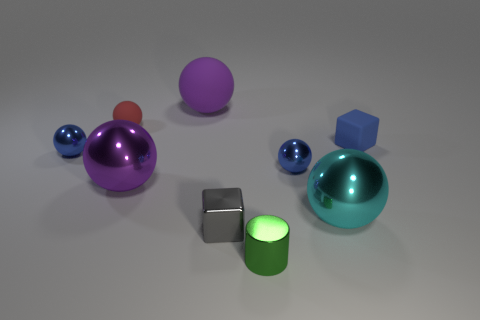Do the green object and the blue cube have the same size?
Your answer should be compact. Yes. Is the number of tiny shiny blocks behind the blue rubber block greater than the number of purple rubber spheres to the right of the cyan thing?
Make the answer very short. No. How many other things are the same size as the shiny cube?
Your answer should be very brief. 5. Is the color of the large metal thing that is on the right side of the purple matte ball the same as the tiny rubber ball?
Provide a short and direct response. No. Is the number of cyan balls that are left of the tiny gray object greater than the number of red metallic cylinders?
Offer a very short reply. No. Is there any other thing that has the same color as the small cylinder?
Provide a short and direct response. No. The big purple object behind the small thing that is behind the tiny blue rubber thing is what shape?
Keep it short and to the point. Sphere. Are there more tiny cyan spheres than small blue rubber objects?
Give a very brief answer. No. How many rubber things are both on the right side of the purple shiny sphere and on the left side of the tiny blue block?
Offer a very short reply. 1. There is a block that is in front of the cyan thing; how many tiny metal blocks are behind it?
Ensure brevity in your answer.  0. 